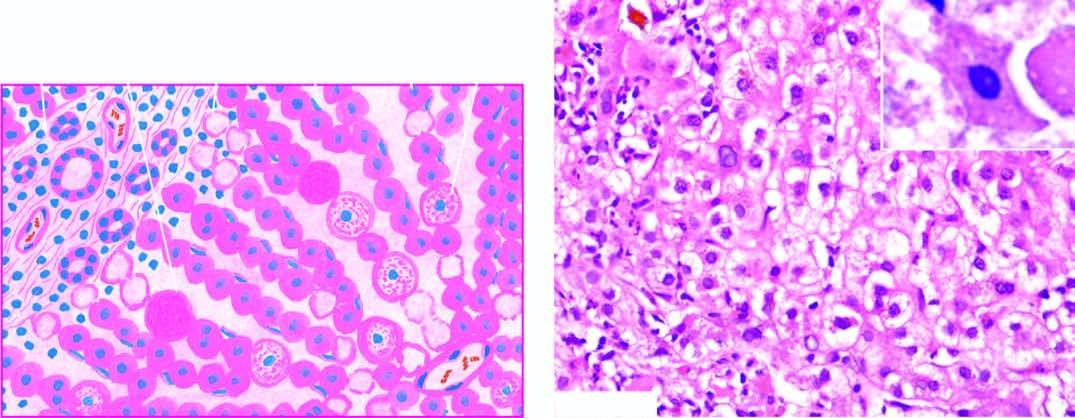s mild degree of liver cell necrosis seen as ballooning degeneration while acidophilic councilman bodies are indicative of more severe liver cell injury?
Answer the question using a single word or phrase. Yes 